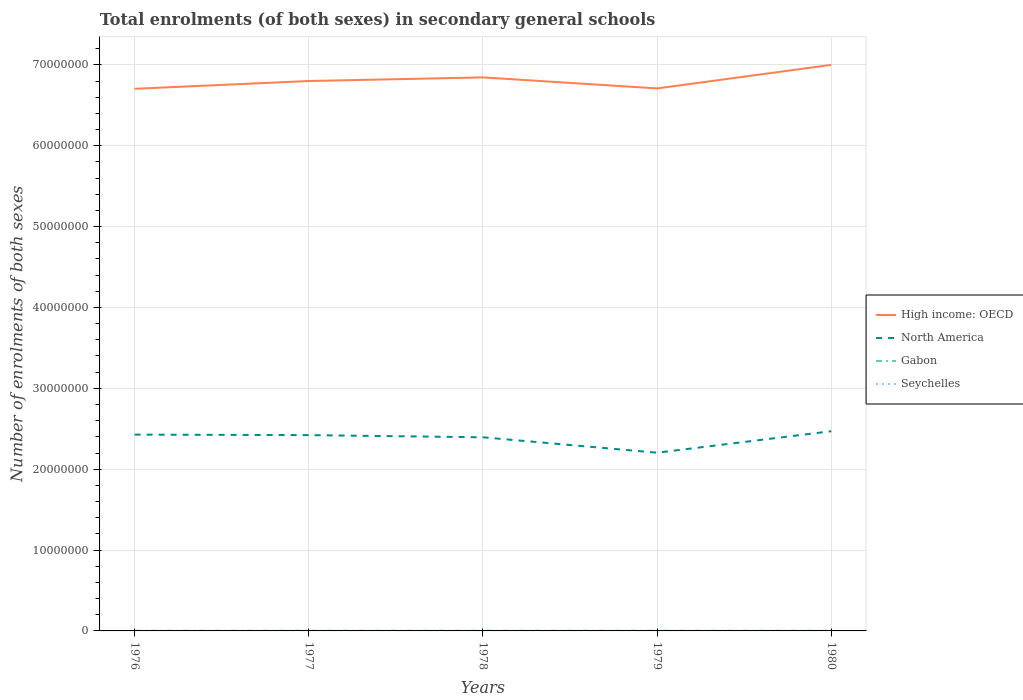Does the line corresponding to Seychelles intersect with the line corresponding to High income: OECD?
Ensure brevity in your answer.  No. Across all years, what is the maximum number of enrolments in secondary schools in Seychelles?
Keep it short and to the point. 3036. In which year was the number of enrolments in secondary schools in High income: OECD maximum?
Keep it short and to the point. 1976. What is the total number of enrolments in secondary schools in North America in the graph?
Keep it short and to the point. 6.24e+04. What is the difference between the highest and the second highest number of enrolments in secondary schools in North America?
Provide a succinct answer. 2.66e+06. What is the difference between the highest and the lowest number of enrolments in secondary schools in High income: OECD?
Ensure brevity in your answer.  2. How many lines are there?
Offer a very short reply. 4. How many years are there in the graph?
Your response must be concise. 5. Are the values on the major ticks of Y-axis written in scientific E-notation?
Your response must be concise. No. Does the graph contain grids?
Provide a succinct answer. Yes. How are the legend labels stacked?
Your response must be concise. Vertical. What is the title of the graph?
Offer a terse response. Total enrolments (of both sexes) in secondary general schools. Does "Finland" appear as one of the legend labels in the graph?
Your answer should be very brief. No. What is the label or title of the X-axis?
Keep it short and to the point. Years. What is the label or title of the Y-axis?
Your response must be concise. Number of enrolments of both sexes. What is the Number of enrolments of both sexes of High income: OECD in 1976?
Keep it short and to the point. 6.70e+07. What is the Number of enrolments of both sexes of North America in 1976?
Make the answer very short. 2.43e+07. What is the Number of enrolments of both sexes of Gabon in 1976?
Offer a terse response. 1.97e+04. What is the Number of enrolments of both sexes of Seychelles in 1976?
Keep it short and to the point. 3036. What is the Number of enrolments of both sexes in High income: OECD in 1977?
Provide a short and direct response. 6.80e+07. What is the Number of enrolments of both sexes in North America in 1977?
Offer a terse response. 2.42e+07. What is the Number of enrolments of both sexes in Gabon in 1977?
Give a very brief answer. 2.04e+04. What is the Number of enrolments of both sexes in Seychelles in 1977?
Offer a terse response. 4243. What is the Number of enrolments of both sexes of High income: OECD in 1978?
Provide a short and direct response. 6.84e+07. What is the Number of enrolments of both sexes in North America in 1978?
Offer a very short reply. 2.39e+07. What is the Number of enrolments of both sexes in Gabon in 1978?
Provide a short and direct response. 2.16e+04. What is the Number of enrolments of both sexes in Seychelles in 1978?
Make the answer very short. 4361. What is the Number of enrolments of both sexes in High income: OECD in 1979?
Your response must be concise. 6.71e+07. What is the Number of enrolments of both sexes of North America in 1979?
Give a very brief answer. 2.20e+07. What is the Number of enrolments of both sexes of Gabon in 1979?
Your answer should be very brief. 2.03e+04. What is the Number of enrolments of both sexes in Seychelles in 1979?
Ensure brevity in your answer.  4601. What is the Number of enrolments of both sexes of High income: OECD in 1980?
Offer a very short reply. 7.00e+07. What is the Number of enrolments of both sexes of North America in 1980?
Give a very brief answer. 2.47e+07. What is the Number of enrolments of both sexes in Gabon in 1980?
Your response must be concise. 1.92e+04. What is the Number of enrolments of both sexes of Seychelles in 1980?
Ensure brevity in your answer.  5317. Across all years, what is the maximum Number of enrolments of both sexes of High income: OECD?
Offer a terse response. 7.00e+07. Across all years, what is the maximum Number of enrolments of both sexes in North America?
Provide a succinct answer. 2.47e+07. Across all years, what is the maximum Number of enrolments of both sexes in Gabon?
Provide a succinct answer. 2.16e+04. Across all years, what is the maximum Number of enrolments of both sexes of Seychelles?
Your response must be concise. 5317. Across all years, what is the minimum Number of enrolments of both sexes of High income: OECD?
Offer a terse response. 6.70e+07. Across all years, what is the minimum Number of enrolments of both sexes of North America?
Your answer should be very brief. 2.20e+07. Across all years, what is the minimum Number of enrolments of both sexes of Gabon?
Offer a very short reply. 1.92e+04. Across all years, what is the minimum Number of enrolments of both sexes of Seychelles?
Make the answer very short. 3036. What is the total Number of enrolments of both sexes of High income: OECD in the graph?
Offer a very short reply. 3.41e+08. What is the total Number of enrolments of both sexes of North America in the graph?
Your answer should be compact. 1.19e+08. What is the total Number of enrolments of both sexes in Gabon in the graph?
Provide a succinct answer. 1.01e+05. What is the total Number of enrolments of both sexes in Seychelles in the graph?
Keep it short and to the point. 2.16e+04. What is the difference between the Number of enrolments of both sexes in High income: OECD in 1976 and that in 1977?
Your answer should be compact. -9.63e+05. What is the difference between the Number of enrolments of both sexes in North America in 1976 and that in 1977?
Your answer should be very brief. 6.24e+04. What is the difference between the Number of enrolments of both sexes in Gabon in 1976 and that in 1977?
Ensure brevity in your answer.  -646. What is the difference between the Number of enrolments of both sexes in Seychelles in 1976 and that in 1977?
Your answer should be very brief. -1207. What is the difference between the Number of enrolments of both sexes in High income: OECD in 1976 and that in 1978?
Keep it short and to the point. -1.41e+06. What is the difference between the Number of enrolments of both sexes of North America in 1976 and that in 1978?
Offer a very short reply. 3.31e+05. What is the difference between the Number of enrolments of both sexes of Gabon in 1976 and that in 1978?
Offer a terse response. -1893. What is the difference between the Number of enrolments of both sexes in Seychelles in 1976 and that in 1978?
Your response must be concise. -1325. What is the difference between the Number of enrolments of both sexes of High income: OECD in 1976 and that in 1979?
Keep it short and to the point. -4.71e+04. What is the difference between the Number of enrolments of both sexes of North America in 1976 and that in 1979?
Provide a short and direct response. 2.24e+06. What is the difference between the Number of enrolments of both sexes of Gabon in 1976 and that in 1979?
Keep it short and to the point. -623. What is the difference between the Number of enrolments of both sexes of Seychelles in 1976 and that in 1979?
Your answer should be compact. -1565. What is the difference between the Number of enrolments of both sexes of High income: OECD in 1976 and that in 1980?
Provide a succinct answer. -2.96e+06. What is the difference between the Number of enrolments of both sexes in North America in 1976 and that in 1980?
Keep it short and to the point. -4.20e+05. What is the difference between the Number of enrolments of both sexes of Gabon in 1976 and that in 1980?
Give a very brief answer. 548. What is the difference between the Number of enrolments of both sexes in Seychelles in 1976 and that in 1980?
Offer a terse response. -2281. What is the difference between the Number of enrolments of both sexes of High income: OECD in 1977 and that in 1978?
Your answer should be compact. -4.49e+05. What is the difference between the Number of enrolments of both sexes of North America in 1977 and that in 1978?
Your response must be concise. 2.69e+05. What is the difference between the Number of enrolments of both sexes of Gabon in 1977 and that in 1978?
Your response must be concise. -1247. What is the difference between the Number of enrolments of both sexes in Seychelles in 1977 and that in 1978?
Ensure brevity in your answer.  -118. What is the difference between the Number of enrolments of both sexes of High income: OECD in 1977 and that in 1979?
Your answer should be very brief. 9.16e+05. What is the difference between the Number of enrolments of both sexes of North America in 1977 and that in 1979?
Keep it short and to the point. 2.18e+06. What is the difference between the Number of enrolments of both sexes in Seychelles in 1977 and that in 1979?
Provide a succinct answer. -358. What is the difference between the Number of enrolments of both sexes in High income: OECD in 1977 and that in 1980?
Provide a succinct answer. -2.00e+06. What is the difference between the Number of enrolments of both sexes in North America in 1977 and that in 1980?
Ensure brevity in your answer.  -4.82e+05. What is the difference between the Number of enrolments of both sexes in Gabon in 1977 and that in 1980?
Keep it short and to the point. 1194. What is the difference between the Number of enrolments of both sexes of Seychelles in 1977 and that in 1980?
Ensure brevity in your answer.  -1074. What is the difference between the Number of enrolments of both sexes of High income: OECD in 1978 and that in 1979?
Your answer should be very brief. 1.36e+06. What is the difference between the Number of enrolments of both sexes in North America in 1978 and that in 1979?
Your response must be concise. 1.91e+06. What is the difference between the Number of enrolments of both sexes in Gabon in 1978 and that in 1979?
Offer a terse response. 1270. What is the difference between the Number of enrolments of both sexes in Seychelles in 1978 and that in 1979?
Your answer should be compact. -240. What is the difference between the Number of enrolments of both sexes in High income: OECD in 1978 and that in 1980?
Your answer should be compact. -1.55e+06. What is the difference between the Number of enrolments of both sexes of North America in 1978 and that in 1980?
Your response must be concise. -7.51e+05. What is the difference between the Number of enrolments of both sexes of Gabon in 1978 and that in 1980?
Ensure brevity in your answer.  2441. What is the difference between the Number of enrolments of both sexes in Seychelles in 1978 and that in 1980?
Ensure brevity in your answer.  -956. What is the difference between the Number of enrolments of both sexes in High income: OECD in 1979 and that in 1980?
Provide a short and direct response. -2.91e+06. What is the difference between the Number of enrolments of both sexes in North America in 1979 and that in 1980?
Make the answer very short. -2.66e+06. What is the difference between the Number of enrolments of both sexes in Gabon in 1979 and that in 1980?
Ensure brevity in your answer.  1171. What is the difference between the Number of enrolments of both sexes in Seychelles in 1979 and that in 1980?
Ensure brevity in your answer.  -716. What is the difference between the Number of enrolments of both sexes in High income: OECD in 1976 and the Number of enrolments of both sexes in North America in 1977?
Ensure brevity in your answer.  4.28e+07. What is the difference between the Number of enrolments of both sexes of High income: OECD in 1976 and the Number of enrolments of both sexes of Gabon in 1977?
Offer a terse response. 6.70e+07. What is the difference between the Number of enrolments of both sexes of High income: OECD in 1976 and the Number of enrolments of both sexes of Seychelles in 1977?
Your answer should be very brief. 6.70e+07. What is the difference between the Number of enrolments of both sexes in North America in 1976 and the Number of enrolments of both sexes in Gabon in 1977?
Give a very brief answer. 2.43e+07. What is the difference between the Number of enrolments of both sexes of North America in 1976 and the Number of enrolments of both sexes of Seychelles in 1977?
Give a very brief answer. 2.43e+07. What is the difference between the Number of enrolments of both sexes in Gabon in 1976 and the Number of enrolments of both sexes in Seychelles in 1977?
Your answer should be compact. 1.55e+04. What is the difference between the Number of enrolments of both sexes of High income: OECD in 1976 and the Number of enrolments of both sexes of North America in 1978?
Your response must be concise. 4.31e+07. What is the difference between the Number of enrolments of both sexes of High income: OECD in 1976 and the Number of enrolments of both sexes of Gabon in 1978?
Ensure brevity in your answer.  6.70e+07. What is the difference between the Number of enrolments of both sexes in High income: OECD in 1976 and the Number of enrolments of both sexes in Seychelles in 1978?
Your answer should be very brief. 6.70e+07. What is the difference between the Number of enrolments of both sexes in North America in 1976 and the Number of enrolments of both sexes in Gabon in 1978?
Provide a succinct answer. 2.43e+07. What is the difference between the Number of enrolments of both sexes in North America in 1976 and the Number of enrolments of both sexes in Seychelles in 1978?
Give a very brief answer. 2.43e+07. What is the difference between the Number of enrolments of both sexes of Gabon in 1976 and the Number of enrolments of both sexes of Seychelles in 1978?
Your answer should be compact. 1.54e+04. What is the difference between the Number of enrolments of both sexes in High income: OECD in 1976 and the Number of enrolments of both sexes in North America in 1979?
Keep it short and to the point. 4.50e+07. What is the difference between the Number of enrolments of both sexes in High income: OECD in 1976 and the Number of enrolments of both sexes in Gabon in 1979?
Provide a succinct answer. 6.70e+07. What is the difference between the Number of enrolments of both sexes in High income: OECD in 1976 and the Number of enrolments of both sexes in Seychelles in 1979?
Your answer should be compact. 6.70e+07. What is the difference between the Number of enrolments of both sexes in North America in 1976 and the Number of enrolments of both sexes in Gabon in 1979?
Give a very brief answer. 2.43e+07. What is the difference between the Number of enrolments of both sexes of North America in 1976 and the Number of enrolments of both sexes of Seychelles in 1979?
Your response must be concise. 2.43e+07. What is the difference between the Number of enrolments of both sexes in Gabon in 1976 and the Number of enrolments of both sexes in Seychelles in 1979?
Offer a terse response. 1.51e+04. What is the difference between the Number of enrolments of both sexes of High income: OECD in 1976 and the Number of enrolments of both sexes of North America in 1980?
Provide a succinct answer. 4.23e+07. What is the difference between the Number of enrolments of both sexes of High income: OECD in 1976 and the Number of enrolments of both sexes of Gabon in 1980?
Provide a short and direct response. 6.70e+07. What is the difference between the Number of enrolments of both sexes of High income: OECD in 1976 and the Number of enrolments of both sexes of Seychelles in 1980?
Your answer should be compact. 6.70e+07. What is the difference between the Number of enrolments of both sexes in North America in 1976 and the Number of enrolments of both sexes in Gabon in 1980?
Give a very brief answer. 2.43e+07. What is the difference between the Number of enrolments of both sexes of North America in 1976 and the Number of enrolments of both sexes of Seychelles in 1980?
Your answer should be very brief. 2.43e+07. What is the difference between the Number of enrolments of both sexes of Gabon in 1976 and the Number of enrolments of both sexes of Seychelles in 1980?
Offer a terse response. 1.44e+04. What is the difference between the Number of enrolments of both sexes in High income: OECD in 1977 and the Number of enrolments of both sexes in North America in 1978?
Offer a terse response. 4.41e+07. What is the difference between the Number of enrolments of both sexes in High income: OECD in 1977 and the Number of enrolments of both sexes in Gabon in 1978?
Make the answer very short. 6.80e+07. What is the difference between the Number of enrolments of both sexes in High income: OECD in 1977 and the Number of enrolments of both sexes in Seychelles in 1978?
Your response must be concise. 6.80e+07. What is the difference between the Number of enrolments of both sexes of North America in 1977 and the Number of enrolments of both sexes of Gabon in 1978?
Your response must be concise. 2.42e+07. What is the difference between the Number of enrolments of both sexes in North America in 1977 and the Number of enrolments of both sexes in Seychelles in 1978?
Offer a terse response. 2.42e+07. What is the difference between the Number of enrolments of both sexes in Gabon in 1977 and the Number of enrolments of both sexes in Seychelles in 1978?
Ensure brevity in your answer.  1.60e+04. What is the difference between the Number of enrolments of both sexes of High income: OECD in 1977 and the Number of enrolments of both sexes of North America in 1979?
Give a very brief answer. 4.60e+07. What is the difference between the Number of enrolments of both sexes of High income: OECD in 1977 and the Number of enrolments of both sexes of Gabon in 1979?
Provide a short and direct response. 6.80e+07. What is the difference between the Number of enrolments of both sexes of High income: OECD in 1977 and the Number of enrolments of both sexes of Seychelles in 1979?
Give a very brief answer. 6.80e+07. What is the difference between the Number of enrolments of both sexes in North America in 1977 and the Number of enrolments of both sexes in Gabon in 1979?
Provide a succinct answer. 2.42e+07. What is the difference between the Number of enrolments of both sexes in North America in 1977 and the Number of enrolments of both sexes in Seychelles in 1979?
Offer a terse response. 2.42e+07. What is the difference between the Number of enrolments of both sexes in Gabon in 1977 and the Number of enrolments of both sexes in Seychelles in 1979?
Your answer should be very brief. 1.58e+04. What is the difference between the Number of enrolments of both sexes of High income: OECD in 1977 and the Number of enrolments of both sexes of North America in 1980?
Keep it short and to the point. 4.33e+07. What is the difference between the Number of enrolments of both sexes in High income: OECD in 1977 and the Number of enrolments of both sexes in Gabon in 1980?
Your response must be concise. 6.80e+07. What is the difference between the Number of enrolments of both sexes in High income: OECD in 1977 and the Number of enrolments of both sexes in Seychelles in 1980?
Your answer should be compact. 6.80e+07. What is the difference between the Number of enrolments of both sexes of North America in 1977 and the Number of enrolments of both sexes of Gabon in 1980?
Provide a short and direct response. 2.42e+07. What is the difference between the Number of enrolments of both sexes of North America in 1977 and the Number of enrolments of both sexes of Seychelles in 1980?
Keep it short and to the point. 2.42e+07. What is the difference between the Number of enrolments of both sexes in Gabon in 1977 and the Number of enrolments of both sexes in Seychelles in 1980?
Give a very brief answer. 1.50e+04. What is the difference between the Number of enrolments of both sexes in High income: OECD in 1978 and the Number of enrolments of both sexes in North America in 1979?
Offer a terse response. 4.64e+07. What is the difference between the Number of enrolments of both sexes in High income: OECD in 1978 and the Number of enrolments of both sexes in Gabon in 1979?
Offer a very short reply. 6.84e+07. What is the difference between the Number of enrolments of both sexes in High income: OECD in 1978 and the Number of enrolments of both sexes in Seychelles in 1979?
Offer a terse response. 6.84e+07. What is the difference between the Number of enrolments of both sexes in North America in 1978 and the Number of enrolments of both sexes in Gabon in 1979?
Offer a very short reply. 2.39e+07. What is the difference between the Number of enrolments of both sexes of North America in 1978 and the Number of enrolments of both sexes of Seychelles in 1979?
Offer a terse response. 2.39e+07. What is the difference between the Number of enrolments of both sexes in Gabon in 1978 and the Number of enrolments of both sexes in Seychelles in 1979?
Offer a terse response. 1.70e+04. What is the difference between the Number of enrolments of both sexes of High income: OECD in 1978 and the Number of enrolments of both sexes of North America in 1980?
Your answer should be very brief. 4.38e+07. What is the difference between the Number of enrolments of both sexes in High income: OECD in 1978 and the Number of enrolments of both sexes in Gabon in 1980?
Offer a terse response. 6.84e+07. What is the difference between the Number of enrolments of both sexes of High income: OECD in 1978 and the Number of enrolments of both sexes of Seychelles in 1980?
Offer a terse response. 6.84e+07. What is the difference between the Number of enrolments of both sexes of North America in 1978 and the Number of enrolments of both sexes of Gabon in 1980?
Provide a succinct answer. 2.39e+07. What is the difference between the Number of enrolments of both sexes of North America in 1978 and the Number of enrolments of both sexes of Seychelles in 1980?
Provide a short and direct response. 2.39e+07. What is the difference between the Number of enrolments of both sexes of Gabon in 1978 and the Number of enrolments of both sexes of Seychelles in 1980?
Your answer should be compact. 1.63e+04. What is the difference between the Number of enrolments of both sexes of High income: OECD in 1979 and the Number of enrolments of both sexes of North America in 1980?
Your answer should be compact. 4.24e+07. What is the difference between the Number of enrolments of both sexes of High income: OECD in 1979 and the Number of enrolments of both sexes of Gabon in 1980?
Provide a succinct answer. 6.71e+07. What is the difference between the Number of enrolments of both sexes of High income: OECD in 1979 and the Number of enrolments of both sexes of Seychelles in 1980?
Make the answer very short. 6.71e+07. What is the difference between the Number of enrolments of both sexes in North America in 1979 and the Number of enrolments of both sexes in Gabon in 1980?
Offer a very short reply. 2.20e+07. What is the difference between the Number of enrolments of both sexes of North America in 1979 and the Number of enrolments of both sexes of Seychelles in 1980?
Give a very brief answer. 2.20e+07. What is the difference between the Number of enrolments of both sexes of Gabon in 1979 and the Number of enrolments of both sexes of Seychelles in 1980?
Ensure brevity in your answer.  1.50e+04. What is the average Number of enrolments of both sexes in High income: OECD per year?
Keep it short and to the point. 6.81e+07. What is the average Number of enrolments of both sexes of North America per year?
Ensure brevity in your answer.  2.38e+07. What is the average Number of enrolments of both sexes in Gabon per year?
Make the answer very short. 2.02e+04. What is the average Number of enrolments of both sexes in Seychelles per year?
Give a very brief answer. 4311.6. In the year 1976, what is the difference between the Number of enrolments of both sexes in High income: OECD and Number of enrolments of both sexes in North America?
Your answer should be compact. 4.28e+07. In the year 1976, what is the difference between the Number of enrolments of both sexes in High income: OECD and Number of enrolments of both sexes in Gabon?
Keep it short and to the point. 6.70e+07. In the year 1976, what is the difference between the Number of enrolments of both sexes of High income: OECD and Number of enrolments of both sexes of Seychelles?
Ensure brevity in your answer.  6.70e+07. In the year 1976, what is the difference between the Number of enrolments of both sexes in North America and Number of enrolments of both sexes in Gabon?
Your response must be concise. 2.43e+07. In the year 1976, what is the difference between the Number of enrolments of both sexes in North America and Number of enrolments of both sexes in Seychelles?
Provide a succinct answer. 2.43e+07. In the year 1976, what is the difference between the Number of enrolments of both sexes of Gabon and Number of enrolments of both sexes of Seychelles?
Offer a terse response. 1.67e+04. In the year 1977, what is the difference between the Number of enrolments of both sexes of High income: OECD and Number of enrolments of both sexes of North America?
Offer a terse response. 4.38e+07. In the year 1977, what is the difference between the Number of enrolments of both sexes in High income: OECD and Number of enrolments of both sexes in Gabon?
Offer a very short reply. 6.80e+07. In the year 1977, what is the difference between the Number of enrolments of both sexes in High income: OECD and Number of enrolments of both sexes in Seychelles?
Ensure brevity in your answer.  6.80e+07. In the year 1977, what is the difference between the Number of enrolments of both sexes of North America and Number of enrolments of both sexes of Gabon?
Make the answer very short. 2.42e+07. In the year 1977, what is the difference between the Number of enrolments of both sexes of North America and Number of enrolments of both sexes of Seychelles?
Ensure brevity in your answer.  2.42e+07. In the year 1977, what is the difference between the Number of enrolments of both sexes in Gabon and Number of enrolments of both sexes in Seychelles?
Offer a terse response. 1.61e+04. In the year 1978, what is the difference between the Number of enrolments of both sexes of High income: OECD and Number of enrolments of both sexes of North America?
Offer a very short reply. 4.45e+07. In the year 1978, what is the difference between the Number of enrolments of both sexes of High income: OECD and Number of enrolments of both sexes of Gabon?
Offer a very short reply. 6.84e+07. In the year 1978, what is the difference between the Number of enrolments of both sexes in High income: OECD and Number of enrolments of both sexes in Seychelles?
Give a very brief answer. 6.84e+07. In the year 1978, what is the difference between the Number of enrolments of both sexes of North America and Number of enrolments of both sexes of Gabon?
Your answer should be compact. 2.39e+07. In the year 1978, what is the difference between the Number of enrolments of both sexes in North America and Number of enrolments of both sexes in Seychelles?
Offer a terse response. 2.39e+07. In the year 1978, what is the difference between the Number of enrolments of both sexes of Gabon and Number of enrolments of both sexes of Seychelles?
Your answer should be very brief. 1.73e+04. In the year 1979, what is the difference between the Number of enrolments of both sexes in High income: OECD and Number of enrolments of both sexes in North America?
Offer a very short reply. 4.50e+07. In the year 1979, what is the difference between the Number of enrolments of both sexes in High income: OECD and Number of enrolments of both sexes in Gabon?
Keep it short and to the point. 6.71e+07. In the year 1979, what is the difference between the Number of enrolments of both sexes in High income: OECD and Number of enrolments of both sexes in Seychelles?
Your answer should be very brief. 6.71e+07. In the year 1979, what is the difference between the Number of enrolments of both sexes in North America and Number of enrolments of both sexes in Gabon?
Make the answer very short. 2.20e+07. In the year 1979, what is the difference between the Number of enrolments of both sexes in North America and Number of enrolments of both sexes in Seychelles?
Offer a terse response. 2.20e+07. In the year 1979, what is the difference between the Number of enrolments of both sexes of Gabon and Number of enrolments of both sexes of Seychelles?
Offer a terse response. 1.57e+04. In the year 1980, what is the difference between the Number of enrolments of both sexes of High income: OECD and Number of enrolments of both sexes of North America?
Your answer should be very brief. 4.53e+07. In the year 1980, what is the difference between the Number of enrolments of both sexes of High income: OECD and Number of enrolments of both sexes of Gabon?
Keep it short and to the point. 7.00e+07. In the year 1980, what is the difference between the Number of enrolments of both sexes in High income: OECD and Number of enrolments of both sexes in Seychelles?
Your answer should be very brief. 7.00e+07. In the year 1980, what is the difference between the Number of enrolments of both sexes of North America and Number of enrolments of both sexes of Gabon?
Ensure brevity in your answer.  2.47e+07. In the year 1980, what is the difference between the Number of enrolments of both sexes in North America and Number of enrolments of both sexes in Seychelles?
Keep it short and to the point. 2.47e+07. In the year 1980, what is the difference between the Number of enrolments of both sexes in Gabon and Number of enrolments of both sexes in Seychelles?
Provide a succinct answer. 1.39e+04. What is the ratio of the Number of enrolments of both sexes in High income: OECD in 1976 to that in 1977?
Make the answer very short. 0.99. What is the ratio of the Number of enrolments of both sexes of Gabon in 1976 to that in 1977?
Make the answer very short. 0.97. What is the ratio of the Number of enrolments of both sexes of Seychelles in 1976 to that in 1977?
Provide a short and direct response. 0.72. What is the ratio of the Number of enrolments of both sexes of High income: OECD in 1976 to that in 1978?
Offer a terse response. 0.98. What is the ratio of the Number of enrolments of both sexes in North America in 1976 to that in 1978?
Give a very brief answer. 1.01. What is the ratio of the Number of enrolments of both sexes of Gabon in 1976 to that in 1978?
Provide a short and direct response. 0.91. What is the ratio of the Number of enrolments of both sexes in Seychelles in 1976 to that in 1978?
Offer a very short reply. 0.7. What is the ratio of the Number of enrolments of both sexes in High income: OECD in 1976 to that in 1979?
Offer a very short reply. 1. What is the ratio of the Number of enrolments of both sexes of North America in 1976 to that in 1979?
Your answer should be compact. 1.1. What is the ratio of the Number of enrolments of both sexes in Gabon in 1976 to that in 1979?
Ensure brevity in your answer.  0.97. What is the ratio of the Number of enrolments of both sexes in Seychelles in 1976 to that in 1979?
Ensure brevity in your answer.  0.66. What is the ratio of the Number of enrolments of both sexes in High income: OECD in 1976 to that in 1980?
Make the answer very short. 0.96. What is the ratio of the Number of enrolments of both sexes of North America in 1976 to that in 1980?
Provide a succinct answer. 0.98. What is the ratio of the Number of enrolments of both sexes in Gabon in 1976 to that in 1980?
Provide a short and direct response. 1.03. What is the ratio of the Number of enrolments of both sexes in Seychelles in 1976 to that in 1980?
Offer a terse response. 0.57. What is the ratio of the Number of enrolments of both sexes in High income: OECD in 1977 to that in 1978?
Ensure brevity in your answer.  0.99. What is the ratio of the Number of enrolments of both sexes in North America in 1977 to that in 1978?
Keep it short and to the point. 1.01. What is the ratio of the Number of enrolments of both sexes in Gabon in 1977 to that in 1978?
Make the answer very short. 0.94. What is the ratio of the Number of enrolments of both sexes in Seychelles in 1977 to that in 1978?
Provide a succinct answer. 0.97. What is the ratio of the Number of enrolments of both sexes of High income: OECD in 1977 to that in 1979?
Your answer should be compact. 1.01. What is the ratio of the Number of enrolments of both sexes of North America in 1977 to that in 1979?
Provide a succinct answer. 1.1. What is the ratio of the Number of enrolments of both sexes of Seychelles in 1977 to that in 1979?
Your answer should be very brief. 0.92. What is the ratio of the Number of enrolments of both sexes of High income: OECD in 1977 to that in 1980?
Give a very brief answer. 0.97. What is the ratio of the Number of enrolments of both sexes of North America in 1977 to that in 1980?
Provide a succinct answer. 0.98. What is the ratio of the Number of enrolments of both sexes of Gabon in 1977 to that in 1980?
Your answer should be compact. 1.06. What is the ratio of the Number of enrolments of both sexes in Seychelles in 1977 to that in 1980?
Make the answer very short. 0.8. What is the ratio of the Number of enrolments of both sexes in High income: OECD in 1978 to that in 1979?
Keep it short and to the point. 1.02. What is the ratio of the Number of enrolments of both sexes of North America in 1978 to that in 1979?
Offer a very short reply. 1.09. What is the ratio of the Number of enrolments of both sexes of Gabon in 1978 to that in 1979?
Ensure brevity in your answer.  1.06. What is the ratio of the Number of enrolments of both sexes of Seychelles in 1978 to that in 1979?
Ensure brevity in your answer.  0.95. What is the ratio of the Number of enrolments of both sexes of High income: OECD in 1978 to that in 1980?
Offer a terse response. 0.98. What is the ratio of the Number of enrolments of both sexes in North America in 1978 to that in 1980?
Your answer should be very brief. 0.97. What is the ratio of the Number of enrolments of both sexes in Gabon in 1978 to that in 1980?
Your answer should be compact. 1.13. What is the ratio of the Number of enrolments of both sexes of Seychelles in 1978 to that in 1980?
Offer a terse response. 0.82. What is the ratio of the Number of enrolments of both sexes in High income: OECD in 1979 to that in 1980?
Your response must be concise. 0.96. What is the ratio of the Number of enrolments of both sexes of North America in 1979 to that in 1980?
Your response must be concise. 0.89. What is the ratio of the Number of enrolments of both sexes in Gabon in 1979 to that in 1980?
Make the answer very short. 1.06. What is the ratio of the Number of enrolments of both sexes in Seychelles in 1979 to that in 1980?
Make the answer very short. 0.87. What is the difference between the highest and the second highest Number of enrolments of both sexes of High income: OECD?
Provide a succinct answer. 1.55e+06. What is the difference between the highest and the second highest Number of enrolments of both sexes of North America?
Offer a very short reply. 4.20e+05. What is the difference between the highest and the second highest Number of enrolments of both sexes of Gabon?
Ensure brevity in your answer.  1247. What is the difference between the highest and the second highest Number of enrolments of both sexes of Seychelles?
Make the answer very short. 716. What is the difference between the highest and the lowest Number of enrolments of both sexes of High income: OECD?
Ensure brevity in your answer.  2.96e+06. What is the difference between the highest and the lowest Number of enrolments of both sexes of North America?
Your response must be concise. 2.66e+06. What is the difference between the highest and the lowest Number of enrolments of both sexes of Gabon?
Ensure brevity in your answer.  2441. What is the difference between the highest and the lowest Number of enrolments of both sexes in Seychelles?
Keep it short and to the point. 2281. 